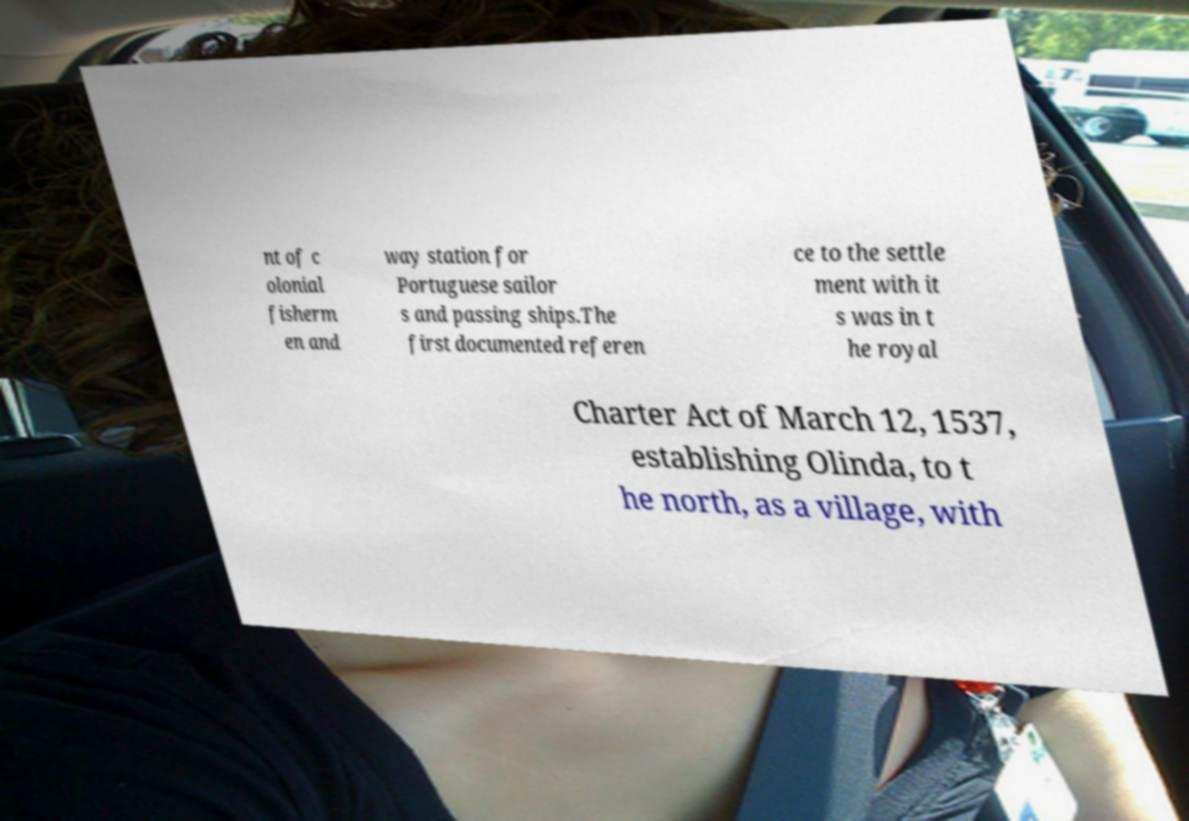There's text embedded in this image that I need extracted. Can you transcribe it verbatim? nt of c olonial fisherm en and way station for Portuguese sailor s and passing ships.The first documented referen ce to the settle ment with it s was in t he royal Charter Act of March 12, 1537, establishing Olinda, to t he north, as a village, with 